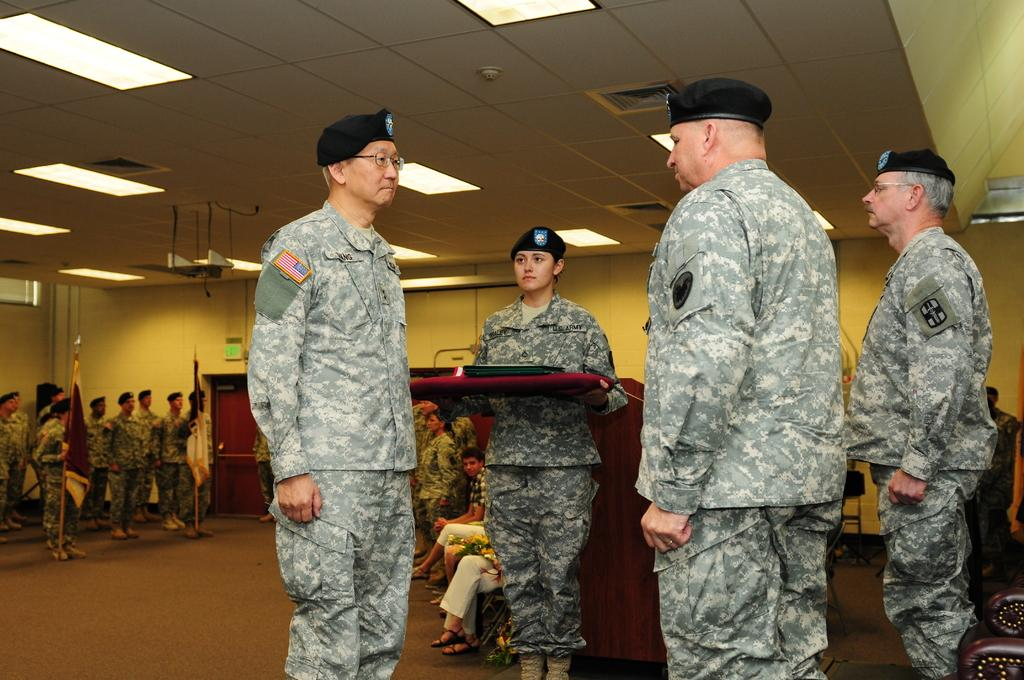How many people are present in the image? There are many people in the image. What are some of the people doing in the image? Some people are sitting, while others are standing. What can be seen in the image in the image besides people? There are flags, chairs, and tables in the image. What type of surprise can be seen on the rat's face in the image? There is no rat present in the image, so it is not possible to answer that question. 